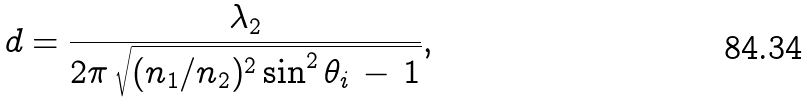Convert formula to latex. <formula><loc_0><loc_0><loc_500><loc_500>d = { \frac { \lambda _ { 2 } } { 2 \pi \, { \sqrt { ( n _ { 1 } / n _ { 2 } ) ^ { 2 } \sin ^ { 2 } \theta _ { i } \, - \, 1 } } } } ,</formula> 